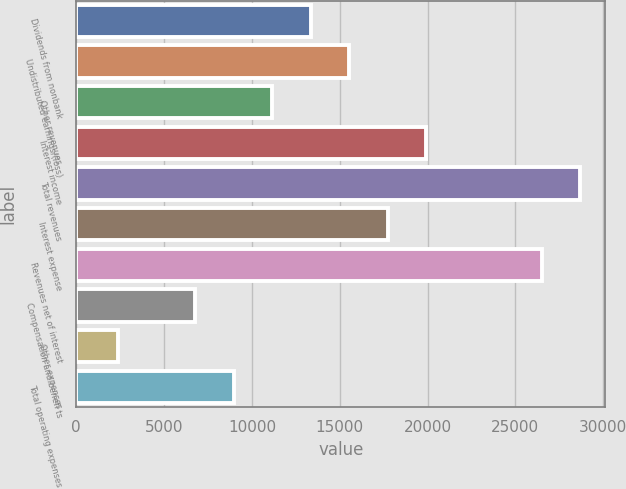<chart> <loc_0><loc_0><loc_500><loc_500><bar_chart><fcel>Dividends from nonbank<fcel>Undistributed earnings/(loss)<fcel>Other revenues<fcel>Interest income<fcel>Total revenues<fcel>Interest expense<fcel>Revenues net of interest<fcel>Compensation and benefi ts<fcel>Other expenses<fcel>Total operating expenses<nl><fcel>13342.8<fcel>15534.6<fcel>11151<fcel>19918.2<fcel>28685.4<fcel>17726.4<fcel>26493.6<fcel>6767.4<fcel>2383.8<fcel>8959.2<nl></chart> 